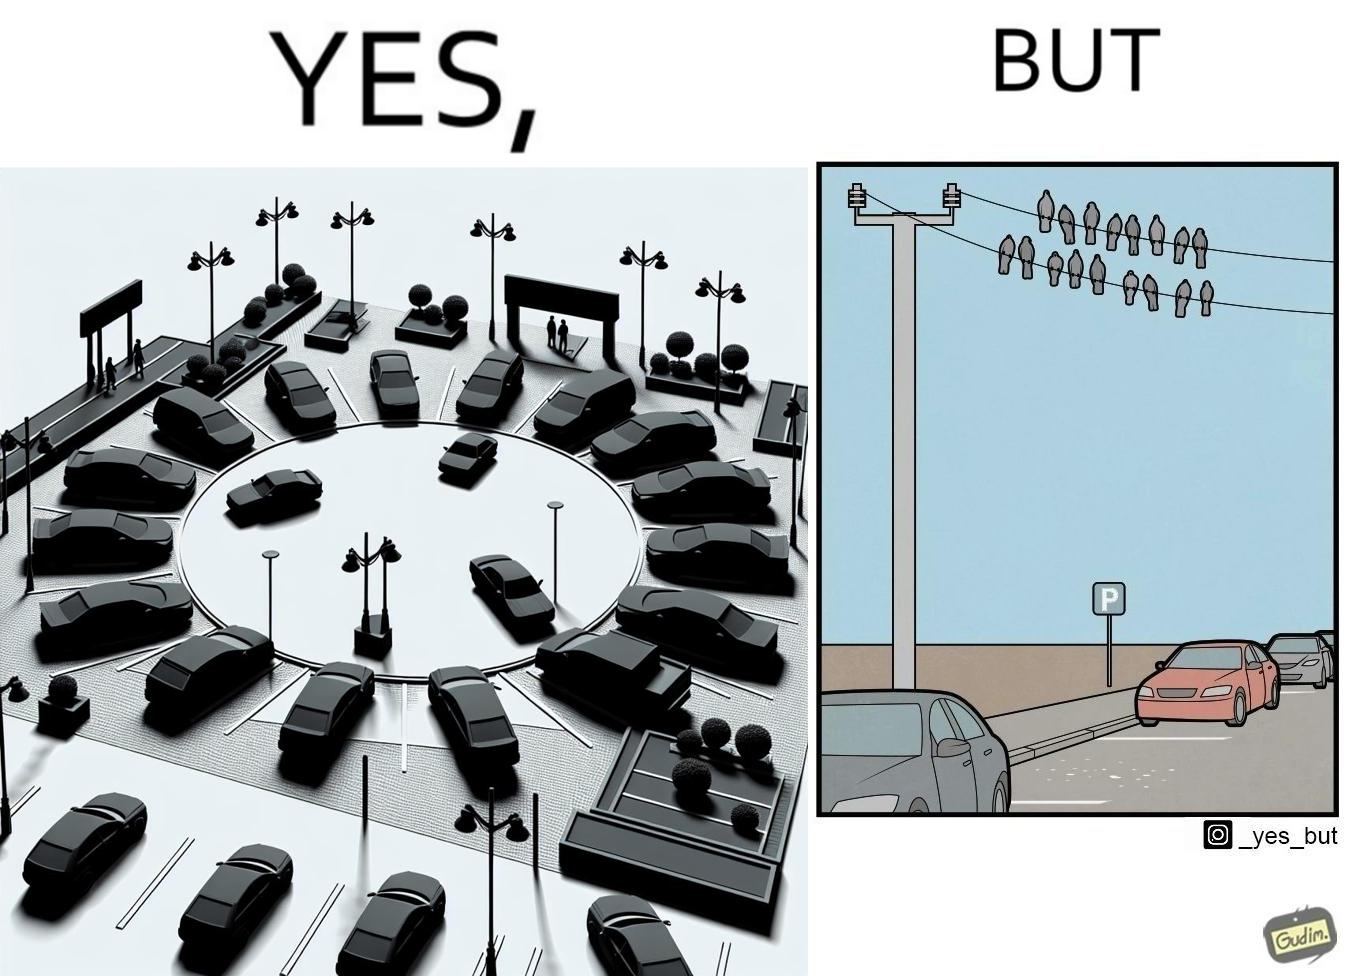Provide a description of this image. The image is ironical such that although there is a place for parking but that place is not suitable because if we place our car there then our car will become dirty from top due to crow beet. 